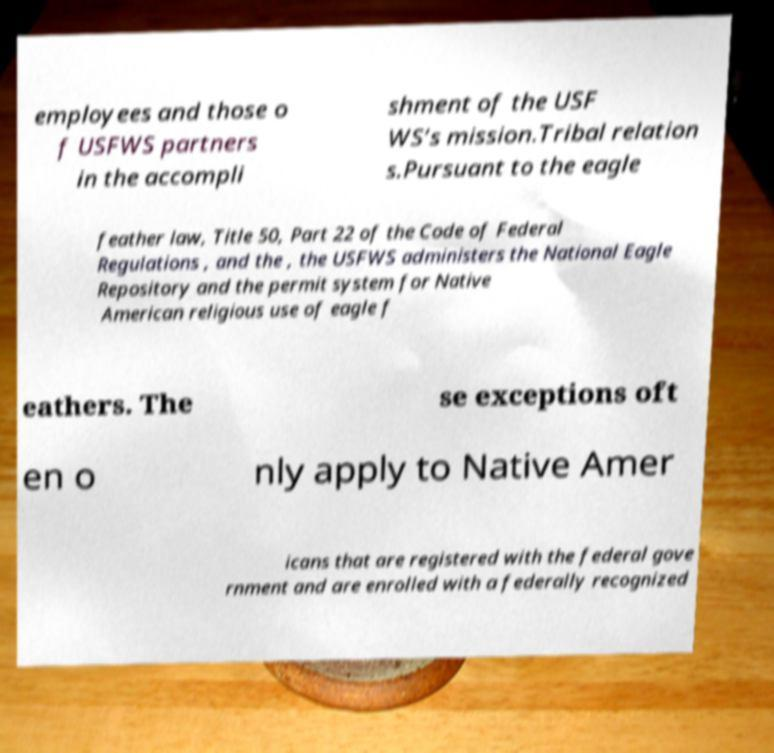There's text embedded in this image that I need extracted. Can you transcribe it verbatim? employees and those o f USFWS partners in the accompli shment of the USF WS’s mission.Tribal relation s.Pursuant to the eagle feather law, Title 50, Part 22 of the Code of Federal Regulations , and the , the USFWS administers the National Eagle Repository and the permit system for Native American religious use of eagle f eathers. The se exceptions oft en o nly apply to Native Amer icans that are registered with the federal gove rnment and are enrolled with a federally recognized 